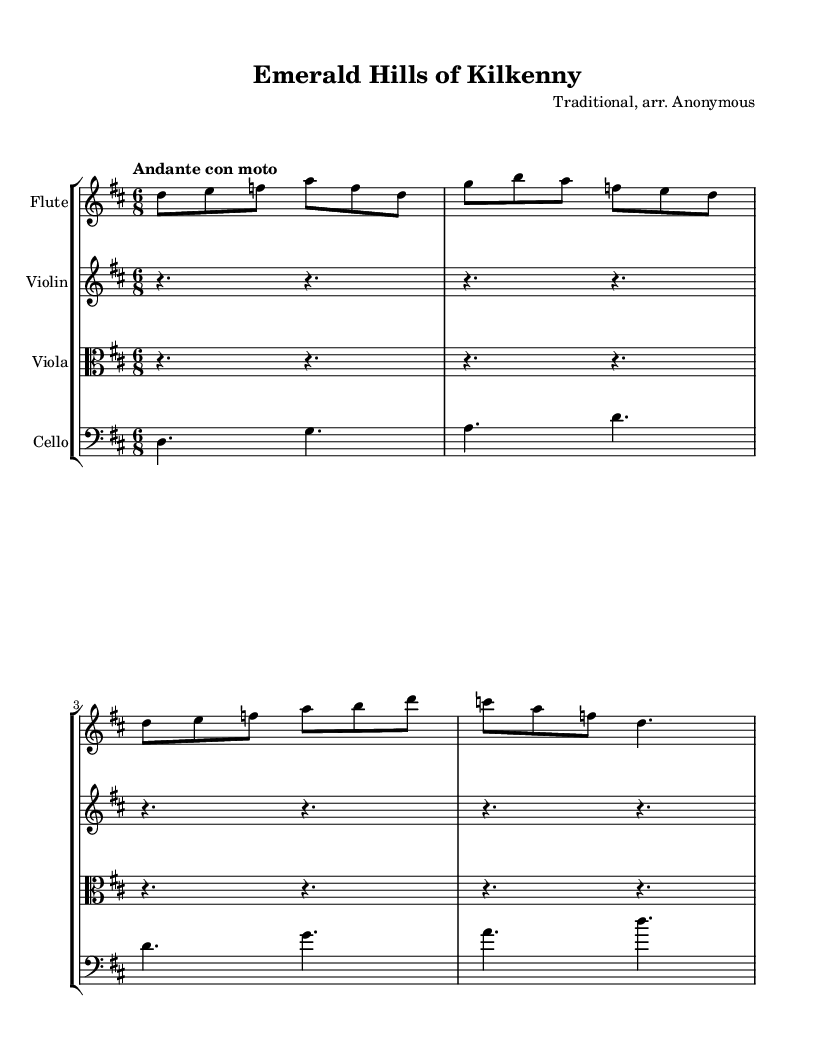What is the key signature of this music? The key signature is D major, which contains two sharps: F# and C#. This can be identified at the beginning of the staff where the sharps are notated.
Answer: D major What is the time signature of this music? The time signature is 6/8, which can be found at the beginning of the score notated right after the clef symbol. In 6/8, there are six eighth notes per measure.
Answer: 6/8 What is the tempo marking for this piece? The tempo marking is "Andante con moto," indicating a moderately slow tempo with some movement. This is stated at the beginning after the time signature.
Answer: Andante con moto How many measures are in the flute part? The flute part contains 6 measures. By counting the vertical lines (bars) in the flute staff, we see there are indeed 6 separations.
Answer: 6 Which instruments are included in the score? The score includes flute, violin, viola, and cello, as indicated by the instrument names listed above each staff. Each staff corresponds to one of these instruments.
Answer: Flute, Violin, Viola, Cello What type of ensemble is indicated by the score? The score indicates a chamber ensemble arrangement, as it includes multiple string and woodwind instruments working together, typically typical for small group settings in classical music.
Answer: Chamber ensemble What is the note length of the first note in the flute part? The first note in the flute part is an eighth note. The note's duration can be identified by its symbol, which resembles a filled note head with a stem and one flag.
Answer: Eighth note 